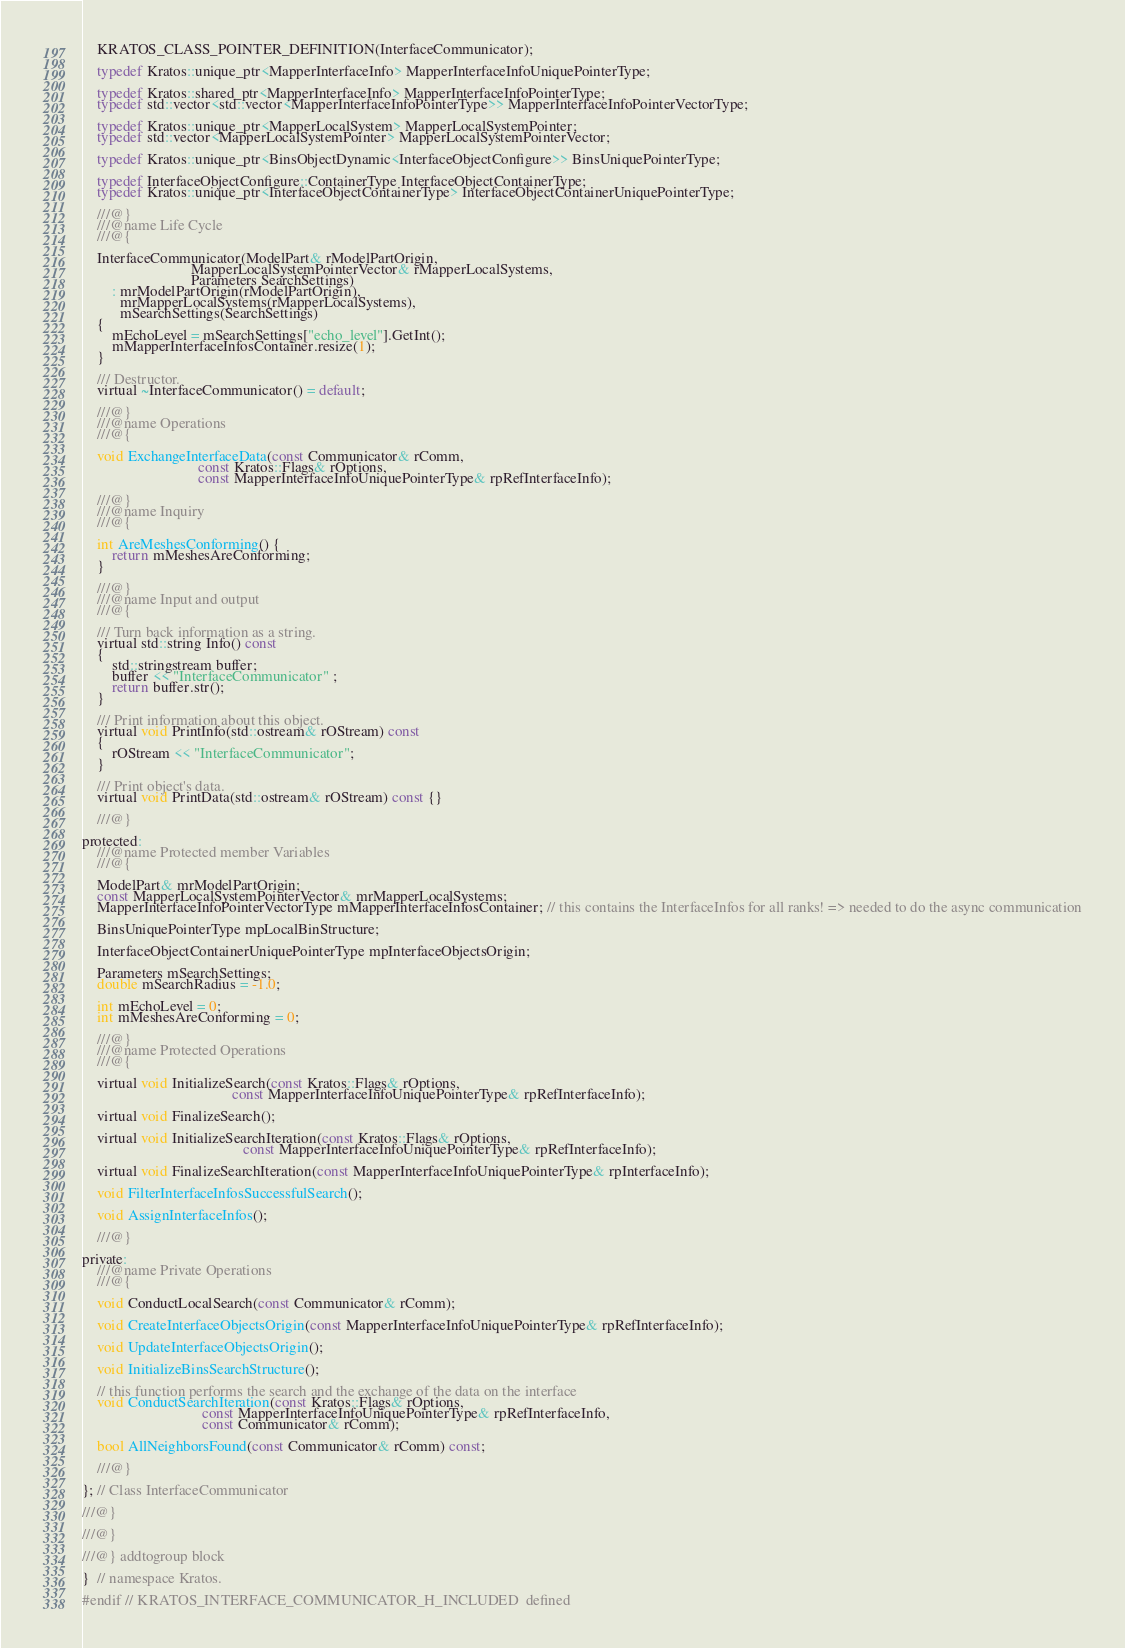Convert code to text. <code><loc_0><loc_0><loc_500><loc_500><_C_>    KRATOS_CLASS_POINTER_DEFINITION(InterfaceCommunicator);

    typedef Kratos::unique_ptr<MapperInterfaceInfo> MapperInterfaceInfoUniquePointerType;

    typedef Kratos::shared_ptr<MapperInterfaceInfo> MapperInterfaceInfoPointerType;
    typedef std::vector<std::vector<MapperInterfaceInfoPointerType>> MapperInterfaceInfoPointerVectorType;

    typedef Kratos::unique_ptr<MapperLocalSystem> MapperLocalSystemPointer;
    typedef std::vector<MapperLocalSystemPointer> MapperLocalSystemPointerVector;

    typedef Kratos::unique_ptr<BinsObjectDynamic<InterfaceObjectConfigure>> BinsUniquePointerType;

    typedef InterfaceObjectConfigure::ContainerType InterfaceObjectContainerType;
    typedef Kratos::unique_ptr<InterfaceObjectContainerType> InterfaceObjectContainerUniquePointerType;

    ///@}
    ///@name Life Cycle
    ///@{

    InterfaceCommunicator(ModelPart& rModelPartOrigin,
                             MapperLocalSystemPointerVector& rMapperLocalSystems,
                             Parameters SearchSettings)
        : mrModelPartOrigin(rModelPartOrigin),
          mrMapperLocalSystems(rMapperLocalSystems),
          mSearchSettings(SearchSettings)
    {
        mEchoLevel = mSearchSettings["echo_level"].GetInt();
        mMapperInterfaceInfosContainer.resize(1);
    }

    /// Destructor.
    virtual ~InterfaceCommunicator() = default;

    ///@}
    ///@name Operations
    ///@{

    void ExchangeInterfaceData(const Communicator& rComm,
                               const Kratos::Flags& rOptions,
                               const MapperInterfaceInfoUniquePointerType& rpRefInterfaceInfo);

    ///@}
    ///@name Inquiry
    ///@{

    int AreMeshesConforming() {
        return mMeshesAreConforming;
    }

    ///@}
    ///@name Input and output
    ///@{

    /// Turn back information as a string.
    virtual std::string Info() const
    {
        std::stringstream buffer;
        buffer << "InterfaceCommunicator" ;
        return buffer.str();
    }

    /// Print information about this object.
    virtual void PrintInfo(std::ostream& rOStream) const
    {
        rOStream << "InterfaceCommunicator";
    }

    /// Print object's data.
    virtual void PrintData(std::ostream& rOStream) const {}

    ///@}

protected:
    ///@name Protected member Variables
    ///@{

    ModelPart& mrModelPartOrigin;
    const MapperLocalSystemPointerVector& mrMapperLocalSystems;
    MapperInterfaceInfoPointerVectorType mMapperInterfaceInfosContainer; // this contains the InterfaceInfos for all ranks! => needed to do the async communication

    BinsUniquePointerType mpLocalBinStructure;

    InterfaceObjectContainerUniquePointerType mpInterfaceObjectsOrigin;

    Parameters mSearchSettings;
    double mSearchRadius = -1.0;

    int mEchoLevel = 0;
    int mMeshesAreConforming = 0;

    ///@}
    ///@name Protected Operations
    ///@{

    virtual void InitializeSearch(const Kratos::Flags& rOptions,
                                        const MapperInterfaceInfoUniquePointerType& rpRefInterfaceInfo);

    virtual void FinalizeSearch();

    virtual void InitializeSearchIteration(const Kratos::Flags& rOptions,
                                           const MapperInterfaceInfoUniquePointerType& rpRefInterfaceInfo);

    virtual void FinalizeSearchIteration(const MapperInterfaceInfoUniquePointerType& rpInterfaceInfo);

    void FilterInterfaceInfosSuccessfulSearch();

    void AssignInterfaceInfos();

    ///@}

private:
    ///@name Private Operations
    ///@{

    void ConductLocalSearch(const Communicator& rComm);

    void CreateInterfaceObjectsOrigin(const MapperInterfaceInfoUniquePointerType& rpRefInterfaceInfo);

    void UpdateInterfaceObjectsOrigin();

    void InitializeBinsSearchStructure();

    // this function performs the search and the exchange of the data on the interface
    void ConductSearchIteration(const Kratos::Flags& rOptions,
                                const MapperInterfaceInfoUniquePointerType& rpRefInterfaceInfo,
                                const Communicator& rComm);

    bool AllNeighborsFound(const Communicator& rComm) const;

    ///@}

}; // Class InterfaceCommunicator

///@}

///@}

///@} addtogroup block

}  // namespace Kratos.

#endif // KRATOS_INTERFACE_COMMUNICATOR_H_INCLUDED  defined
</code> 